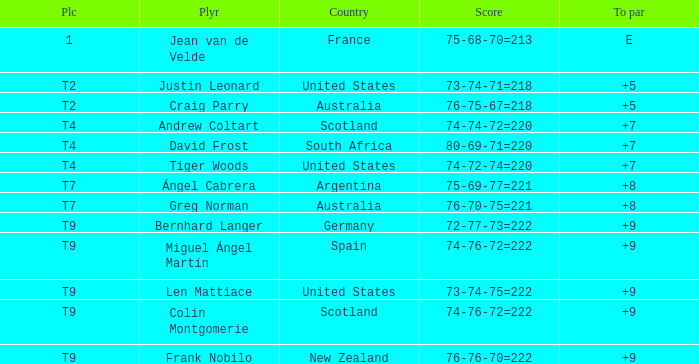What is the place number for the player with a To Par score of 'E'? 1.0. Would you mind parsing the complete table? {'header': ['Plc', 'Plyr', 'Country', 'Score', 'To par'], 'rows': [['1', 'Jean van de Velde', 'France', '75-68-70=213', 'E'], ['T2', 'Justin Leonard', 'United States', '73-74-71=218', '+5'], ['T2', 'Craig Parry', 'Australia', '76-75-67=218', '+5'], ['T4', 'Andrew Coltart', 'Scotland', '74-74-72=220', '+7'], ['T4', 'David Frost', 'South Africa', '80-69-71=220', '+7'], ['T4', 'Tiger Woods', 'United States', '74-72-74=220', '+7'], ['T7', 'Ángel Cabrera', 'Argentina', '75-69-77=221', '+8'], ['T7', 'Greg Norman', 'Australia', '76-70-75=221', '+8'], ['T9', 'Bernhard Langer', 'Germany', '72-77-73=222', '+9'], ['T9', 'Miguel Ángel Martín', 'Spain', '74-76-72=222', '+9'], ['T9', 'Len Mattiace', 'United States', '73-74-75=222', '+9'], ['T9', 'Colin Montgomerie', 'Scotland', '74-76-72=222', '+9'], ['T9', 'Frank Nobilo', 'New Zealand', '76-76-70=222', '+9']]} 